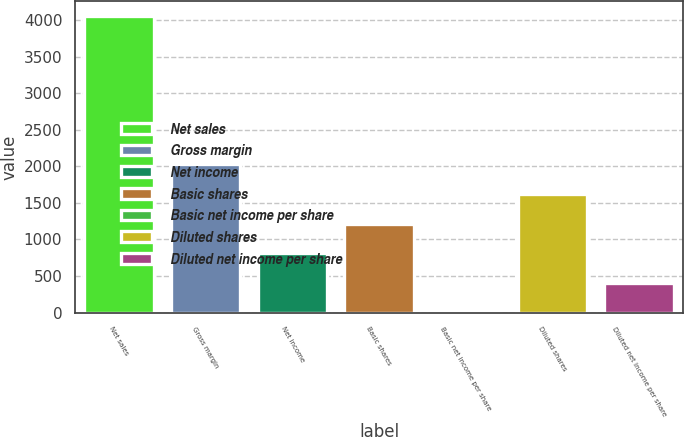<chart> <loc_0><loc_0><loc_500><loc_500><bar_chart><fcel>Net sales<fcel>Gross margin<fcel>Net income<fcel>Basic shares<fcel>Basic net income per share<fcel>Diluted shares<fcel>Diluted net income per share<nl><fcel>4051<fcel>2025.83<fcel>810.71<fcel>1215.75<fcel>0.63<fcel>1620.79<fcel>405.67<nl></chart> 